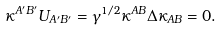Convert formula to latex. <formula><loc_0><loc_0><loc_500><loc_500>\kappa ^ { A ^ { \prime } B ^ { \prime } } U _ { A ^ { \prime } B ^ { \prime } } = \gamma ^ { 1 / 2 } \kappa ^ { A B } \Delta \kappa _ { A B } = 0 .</formula> 